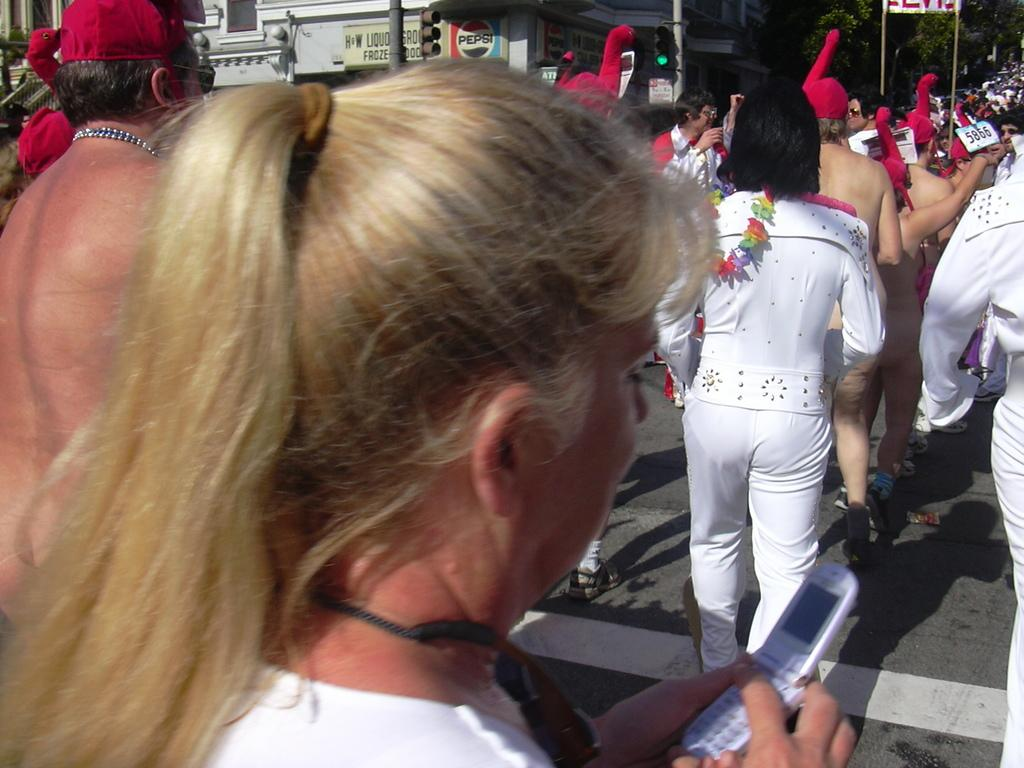What can be seen in the background of the image? There are trees and traffic signals in the background of the image. What is happening on the road in the image? People are visible on the road. Can you describe the woman in the image? A woman is holding a mobile in her hand. Is there a squirrel playing with a bead on the woman's shoulder in the image? No, there is no squirrel or bead present in the image. Who is the woman's partner in the image? There is no information about a partner in the image. 